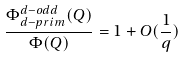<formula> <loc_0><loc_0><loc_500><loc_500>\frac { \Phi _ { d - p r i m } ^ { d - o d d } ( Q ) } { \Phi ( Q ) } = 1 + O ( \frac { 1 } { q } )</formula> 